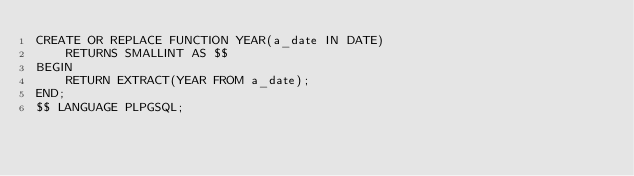<code> <loc_0><loc_0><loc_500><loc_500><_SQL_>CREATE OR REPLACE FUNCTION YEAR(a_date IN DATE)
    RETURNS SMALLINT AS $$
BEGIN
    RETURN EXTRACT(YEAR FROM a_date);
END;
$$ LANGUAGE PLPGSQL;
</code> 